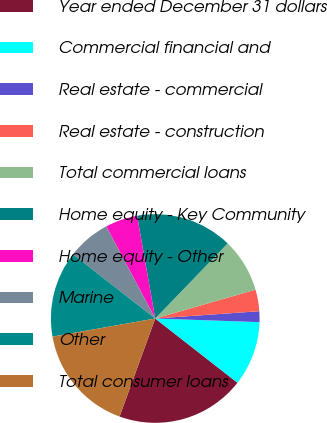Convert chart to OTSL. <chart><loc_0><loc_0><loc_500><loc_500><pie_chart><fcel>Year ended December 31 dollars<fcel>Commercial financial and<fcel>Real estate - commercial<fcel>Real estate - construction<fcel>Total commercial loans<fcel>Home equity - Key Community<fcel>Home equity - Other<fcel>Marine<fcel>Other<fcel>Total consumer loans<nl><fcel>20.0%<fcel>10.0%<fcel>1.67%<fcel>3.34%<fcel>8.33%<fcel>15.0%<fcel>5.0%<fcel>6.67%<fcel>13.33%<fcel>16.66%<nl></chart> 